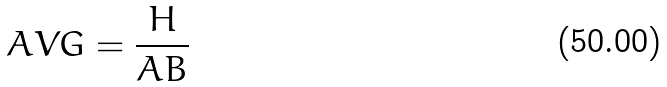<formula> <loc_0><loc_0><loc_500><loc_500>A V G = \frac { H } { A B }</formula> 